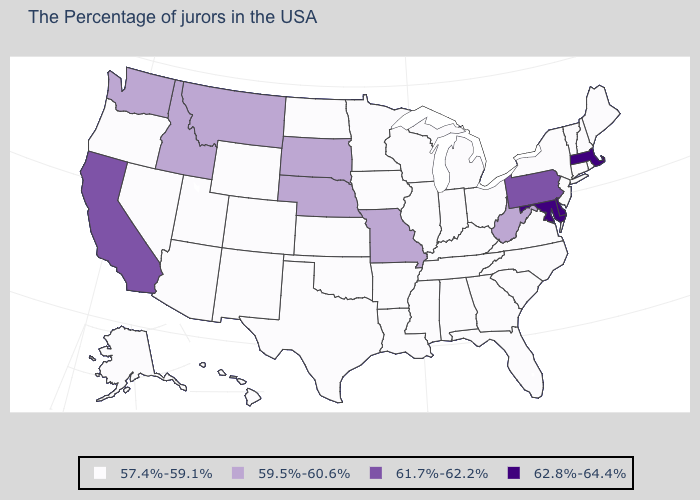What is the highest value in the USA?
Answer briefly. 62.8%-64.4%. What is the highest value in states that border Maryland?
Keep it brief. 62.8%-64.4%. Which states have the lowest value in the USA?
Answer briefly. Maine, Rhode Island, New Hampshire, Vermont, Connecticut, New York, New Jersey, Virginia, North Carolina, South Carolina, Ohio, Florida, Georgia, Michigan, Kentucky, Indiana, Alabama, Tennessee, Wisconsin, Illinois, Mississippi, Louisiana, Arkansas, Minnesota, Iowa, Kansas, Oklahoma, Texas, North Dakota, Wyoming, Colorado, New Mexico, Utah, Arizona, Nevada, Oregon, Alaska, Hawaii. What is the value of Connecticut?
Quick response, please. 57.4%-59.1%. Does the map have missing data?
Write a very short answer. No. Name the states that have a value in the range 59.5%-60.6%?
Write a very short answer. West Virginia, Missouri, Nebraska, South Dakota, Montana, Idaho, Washington. Does Delaware have the lowest value in the USA?
Quick response, please. No. Does Kansas have the lowest value in the USA?
Be succinct. Yes. Name the states that have a value in the range 62.8%-64.4%?
Short answer required. Massachusetts, Delaware, Maryland. What is the value of Mississippi?
Short answer required. 57.4%-59.1%. What is the value of New Jersey?
Short answer required. 57.4%-59.1%. Which states have the lowest value in the USA?
Short answer required. Maine, Rhode Island, New Hampshire, Vermont, Connecticut, New York, New Jersey, Virginia, North Carolina, South Carolina, Ohio, Florida, Georgia, Michigan, Kentucky, Indiana, Alabama, Tennessee, Wisconsin, Illinois, Mississippi, Louisiana, Arkansas, Minnesota, Iowa, Kansas, Oklahoma, Texas, North Dakota, Wyoming, Colorado, New Mexico, Utah, Arizona, Nevada, Oregon, Alaska, Hawaii. Name the states that have a value in the range 62.8%-64.4%?
Concise answer only. Massachusetts, Delaware, Maryland. Name the states that have a value in the range 57.4%-59.1%?
Answer briefly. Maine, Rhode Island, New Hampshire, Vermont, Connecticut, New York, New Jersey, Virginia, North Carolina, South Carolina, Ohio, Florida, Georgia, Michigan, Kentucky, Indiana, Alabama, Tennessee, Wisconsin, Illinois, Mississippi, Louisiana, Arkansas, Minnesota, Iowa, Kansas, Oklahoma, Texas, North Dakota, Wyoming, Colorado, New Mexico, Utah, Arizona, Nevada, Oregon, Alaska, Hawaii. Does the map have missing data?
Keep it brief. No. 